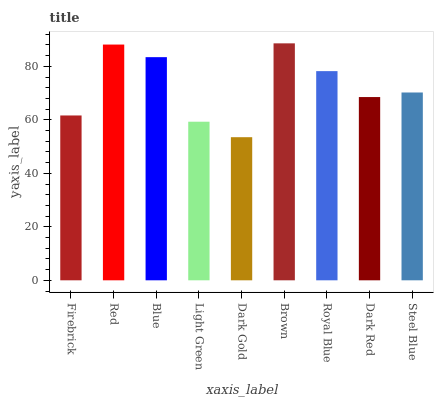Is Dark Gold the minimum?
Answer yes or no. Yes. Is Brown the maximum?
Answer yes or no. Yes. Is Red the minimum?
Answer yes or no. No. Is Red the maximum?
Answer yes or no. No. Is Red greater than Firebrick?
Answer yes or no. Yes. Is Firebrick less than Red?
Answer yes or no. Yes. Is Firebrick greater than Red?
Answer yes or no. No. Is Red less than Firebrick?
Answer yes or no. No. Is Steel Blue the high median?
Answer yes or no. Yes. Is Steel Blue the low median?
Answer yes or no. Yes. Is Brown the high median?
Answer yes or no. No. Is Dark Gold the low median?
Answer yes or no. No. 